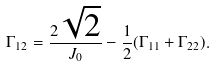<formula> <loc_0><loc_0><loc_500><loc_500>\Gamma _ { 1 2 } = \frac { 2 \sqrt { 2 } } { J _ { 0 } } - \frac { 1 } { 2 } ( \Gamma _ { 1 1 } + \Gamma _ { 2 2 } ) .</formula> 